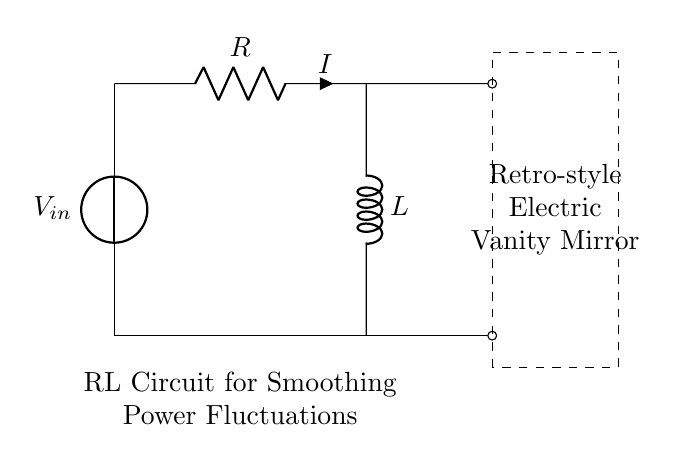What is the input voltage in this circuit? The input voltage is labeled as V_in at the top of the circuit diagram. It indicates the voltage supplied to the circuit.
Answer: V_in What components are present in the circuit? The components in the circuit are a voltage source (V_in), a resistor (R), and an inductor (L). These are the key elements responsible for the circuit's function.
Answer: Voltage source, resistor, inductor What is the direction of the current flow in the circuit? The current flow direction is indicated by the arrow labeled 'i' next to the resistor (R), showing that the current moves from the voltage source through the resistor and inductor.
Answer: From V_in through R to L What purpose does the inductor serve in this circuit? The inductor is used to smooth power fluctuations by resisting changes in current, which is particularly useful in maintaining a stable output for the vanity mirror.
Answer: Smoothing power fluctuations How does the resistor affect the circuit's operation? The resistor limits the current in the circuit according to Ohm's law, which affects the overall impedance and energy dissipation in the RL circuit, allowing it to function properly without overheating.
Answer: Limits current What is the effect of the RL configuration on voltage and current over time? The RL configuration creates a time constant, where the voltage across the inductor and current through it change exponentially with time after a sudden change in voltage, making the circuit response smoother.
Answer: Exponential change How is the circuit relevant for the retro-style electric vanity mirror? This circuit is designed to ensure smooth and consistent power delivery to the electric vanity mirror, preventing flickering or unstable operation which is particularly important for lighting in mirrors.
Answer: Consistent power delivery 